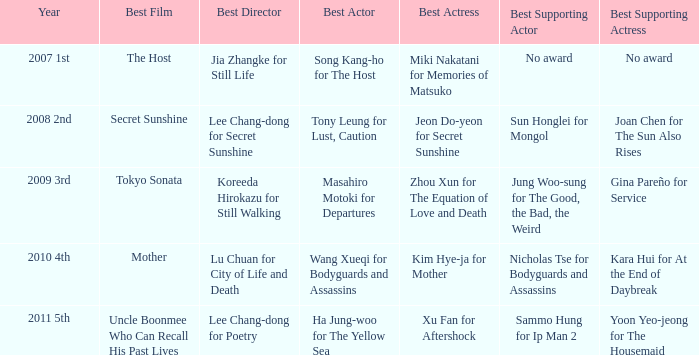Could you help me parse every detail presented in this table? {'header': ['Year', 'Best Film', 'Best Director', 'Best Actor', 'Best Actress', 'Best Supporting Actor', 'Best Supporting Actress'], 'rows': [['2007 1st', 'The Host', 'Jia Zhangke for Still Life', 'Song Kang-ho for The Host', 'Miki Nakatani for Memories of Matsuko', 'No award', 'No award'], ['2008 2nd', 'Secret Sunshine', 'Lee Chang-dong for Secret Sunshine', 'Tony Leung for Lust, Caution', 'Jeon Do-yeon for Secret Sunshine', 'Sun Honglei for Mongol', 'Joan Chen for The Sun Also Rises'], ['2009 3rd', 'Tokyo Sonata', 'Koreeda Hirokazu for Still Walking', 'Masahiro Motoki for Departures', 'Zhou Xun for The Equation of Love and Death', 'Jung Woo-sung for The Good, the Bad, the Weird', 'Gina Pareño for Service'], ['2010 4th', 'Mother', 'Lu Chuan for City of Life and Death', 'Wang Xueqi for Bodyguards and Assassins', 'Kim Hye-ja for Mother', 'Nicholas Tse for Bodyguards and Assassins', 'Kara Hui for At the End of Daybreak'], ['2011 5th', 'Uncle Boonmee Who Can Recall His Past Lives', 'Lee Chang-dong for Poetry', 'Ha Jung-woo for The Yellow Sea', 'Xu Fan for Aftershock', 'Sammo Hung for Ip Man 2', 'Yoon Yeo-jeong for The Housemaid']]} Name the best director for mother Lu Chuan for City of Life and Death. 